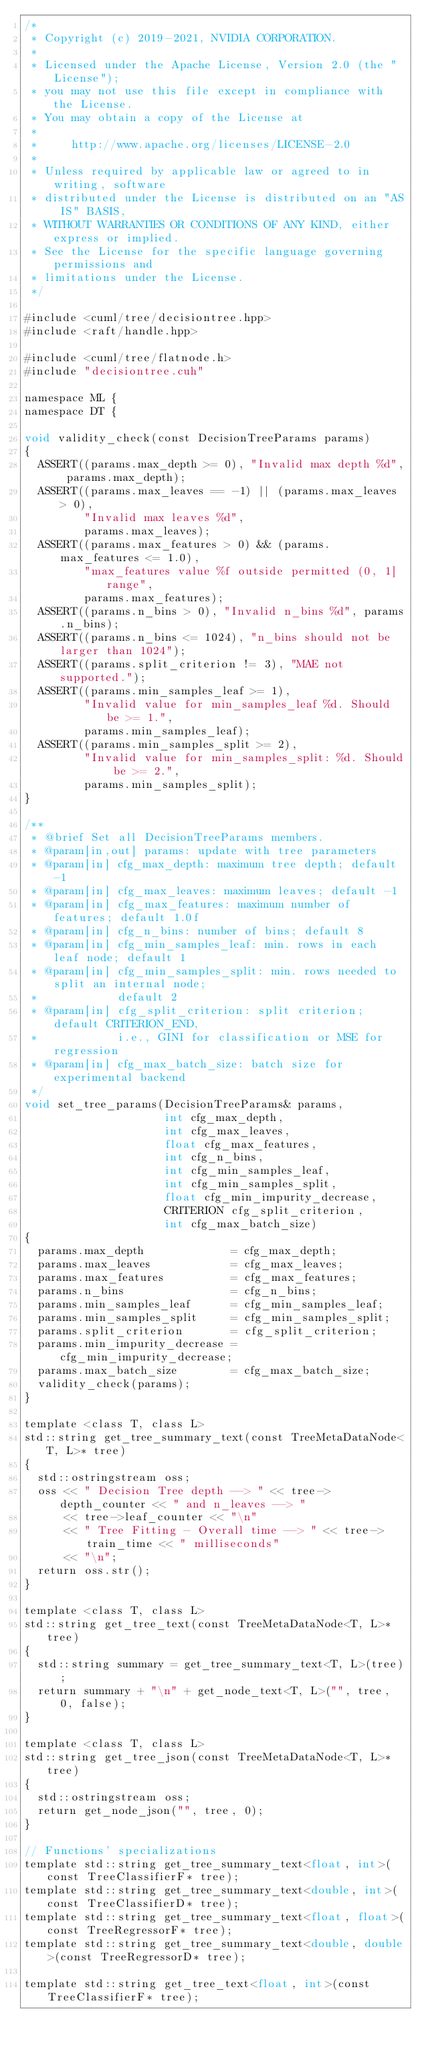Convert code to text. <code><loc_0><loc_0><loc_500><loc_500><_Cuda_>/*
 * Copyright (c) 2019-2021, NVIDIA CORPORATION.
 *
 * Licensed under the Apache License, Version 2.0 (the "License");
 * you may not use this file except in compliance with the License.
 * You may obtain a copy of the License at
 *
 *     http://www.apache.org/licenses/LICENSE-2.0
 *
 * Unless required by applicable law or agreed to in writing, software
 * distributed under the License is distributed on an "AS IS" BASIS,
 * WITHOUT WARRANTIES OR CONDITIONS OF ANY KIND, either express or implied.
 * See the License for the specific language governing permissions and
 * limitations under the License.
 */

#include <cuml/tree/decisiontree.hpp>
#include <raft/handle.hpp>

#include <cuml/tree/flatnode.h>
#include "decisiontree.cuh"

namespace ML {
namespace DT {

void validity_check(const DecisionTreeParams params)
{
  ASSERT((params.max_depth >= 0), "Invalid max depth %d", params.max_depth);
  ASSERT((params.max_leaves == -1) || (params.max_leaves > 0),
         "Invalid max leaves %d",
         params.max_leaves);
  ASSERT((params.max_features > 0) && (params.max_features <= 1.0),
         "max_features value %f outside permitted (0, 1] range",
         params.max_features);
  ASSERT((params.n_bins > 0), "Invalid n_bins %d", params.n_bins);
  ASSERT((params.n_bins <= 1024), "n_bins should not be larger than 1024");
  ASSERT((params.split_criterion != 3), "MAE not supported.");
  ASSERT((params.min_samples_leaf >= 1),
         "Invalid value for min_samples_leaf %d. Should be >= 1.",
         params.min_samples_leaf);
  ASSERT((params.min_samples_split >= 2),
         "Invalid value for min_samples_split: %d. Should be >= 2.",
         params.min_samples_split);
}

/**
 * @brief Set all DecisionTreeParams members.
 * @param[in,out] params: update with tree parameters
 * @param[in] cfg_max_depth: maximum tree depth; default -1
 * @param[in] cfg_max_leaves: maximum leaves; default -1
 * @param[in] cfg_max_features: maximum number of features; default 1.0f
 * @param[in] cfg_n_bins: number of bins; default 8
 * @param[in] cfg_min_samples_leaf: min. rows in each leaf node; default 1
 * @param[in] cfg_min_samples_split: min. rows needed to split an internal node;
 *            default 2
 * @param[in] cfg_split_criterion: split criterion; default CRITERION_END,
 *            i.e., GINI for classification or MSE for regression
 * @param[in] cfg_max_batch_size: batch size for experimental backend
 */
void set_tree_params(DecisionTreeParams& params,
                     int cfg_max_depth,
                     int cfg_max_leaves,
                     float cfg_max_features,
                     int cfg_n_bins,
                     int cfg_min_samples_leaf,
                     int cfg_min_samples_split,
                     float cfg_min_impurity_decrease,
                     CRITERION cfg_split_criterion,
                     int cfg_max_batch_size)
{
  params.max_depth             = cfg_max_depth;
  params.max_leaves            = cfg_max_leaves;
  params.max_features          = cfg_max_features;
  params.n_bins                = cfg_n_bins;
  params.min_samples_leaf      = cfg_min_samples_leaf;
  params.min_samples_split     = cfg_min_samples_split;
  params.split_criterion       = cfg_split_criterion;
  params.min_impurity_decrease = cfg_min_impurity_decrease;
  params.max_batch_size        = cfg_max_batch_size;
  validity_check(params);
}

template <class T, class L>
std::string get_tree_summary_text(const TreeMetaDataNode<T, L>* tree)
{
  std::ostringstream oss;
  oss << " Decision Tree depth --> " << tree->depth_counter << " and n_leaves --> "
      << tree->leaf_counter << "\n"
      << " Tree Fitting - Overall time --> " << tree->train_time << " milliseconds"
      << "\n";
  return oss.str();
}

template <class T, class L>
std::string get_tree_text(const TreeMetaDataNode<T, L>* tree)
{
  std::string summary = get_tree_summary_text<T, L>(tree);
  return summary + "\n" + get_node_text<T, L>("", tree, 0, false);
}

template <class T, class L>
std::string get_tree_json(const TreeMetaDataNode<T, L>* tree)
{
  std::ostringstream oss;
  return get_node_json("", tree, 0);
}

// Functions' specializations
template std::string get_tree_summary_text<float, int>(const TreeClassifierF* tree);
template std::string get_tree_summary_text<double, int>(const TreeClassifierD* tree);
template std::string get_tree_summary_text<float, float>(const TreeRegressorF* tree);
template std::string get_tree_summary_text<double, double>(const TreeRegressorD* tree);

template std::string get_tree_text<float, int>(const TreeClassifierF* tree);</code> 